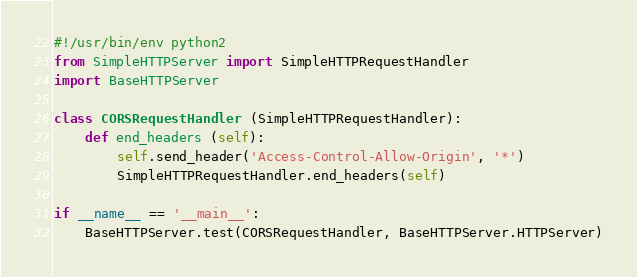Convert code to text. <code><loc_0><loc_0><loc_500><loc_500><_Python_>#!/usr/bin/env python2
from SimpleHTTPServer import SimpleHTTPRequestHandler
import BaseHTTPServer

class CORSRequestHandler (SimpleHTTPRequestHandler):
    def end_headers (self):
        self.send_header('Access-Control-Allow-Origin', '*')
        SimpleHTTPRequestHandler.end_headers(self)

if __name__ == '__main__':
    BaseHTTPServer.test(CORSRequestHandler, BaseHTTPServer.HTTPServer)
</code> 